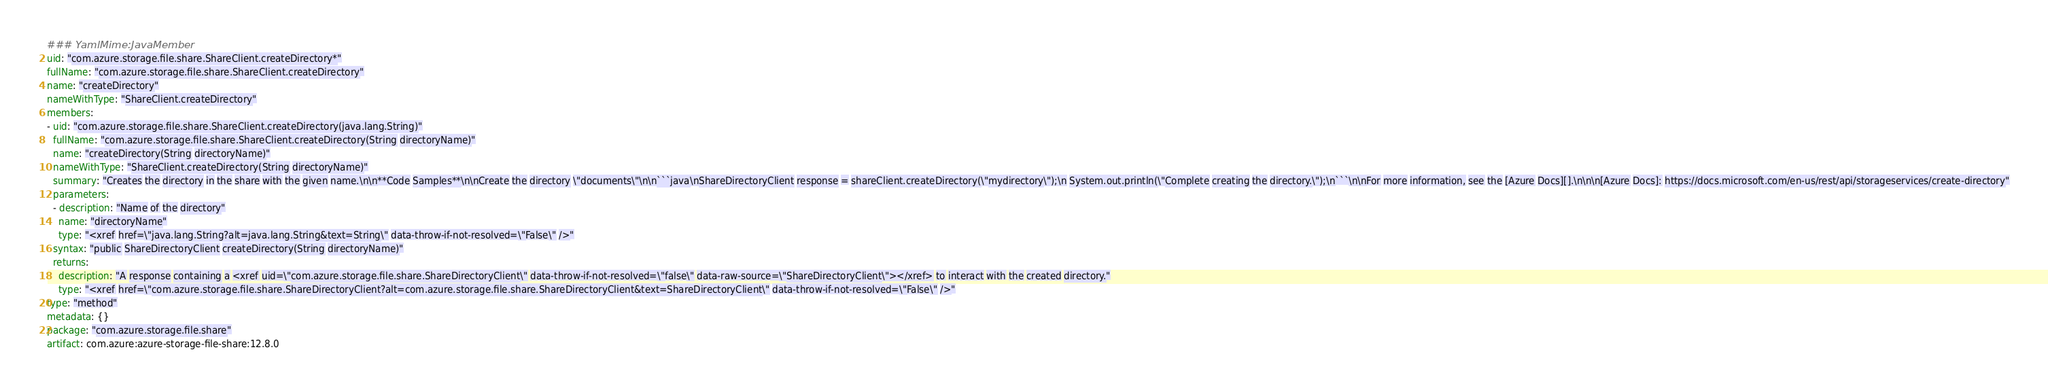<code> <loc_0><loc_0><loc_500><loc_500><_YAML_>### YamlMime:JavaMember
uid: "com.azure.storage.file.share.ShareClient.createDirectory*"
fullName: "com.azure.storage.file.share.ShareClient.createDirectory"
name: "createDirectory"
nameWithType: "ShareClient.createDirectory"
members:
- uid: "com.azure.storage.file.share.ShareClient.createDirectory(java.lang.String)"
  fullName: "com.azure.storage.file.share.ShareClient.createDirectory(String directoryName)"
  name: "createDirectory(String directoryName)"
  nameWithType: "ShareClient.createDirectory(String directoryName)"
  summary: "Creates the directory in the share with the given name.\n\n**Code Samples**\n\nCreate the directory \"documents\"\n\n```java\nShareDirectoryClient response = shareClient.createDirectory(\"mydirectory\");\n System.out.println(\"Complete creating the directory.\");\n```\n\nFor more information, see the [Azure Docs][].\n\n\n[Azure Docs]: https://docs.microsoft.com/en-us/rest/api/storageservices/create-directory"
  parameters:
  - description: "Name of the directory"
    name: "directoryName"
    type: "<xref href=\"java.lang.String?alt=java.lang.String&text=String\" data-throw-if-not-resolved=\"False\" />"
  syntax: "public ShareDirectoryClient createDirectory(String directoryName)"
  returns:
    description: "A response containing a <xref uid=\"com.azure.storage.file.share.ShareDirectoryClient\" data-throw-if-not-resolved=\"false\" data-raw-source=\"ShareDirectoryClient\"></xref> to interact with the created directory."
    type: "<xref href=\"com.azure.storage.file.share.ShareDirectoryClient?alt=com.azure.storage.file.share.ShareDirectoryClient&text=ShareDirectoryClient\" data-throw-if-not-resolved=\"False\" />"
type: "method"
metadata: {}
package: "com.azure.storage.file.share"
artifact: com.azure:azure-storage-file-share:12.8.0
</code> 